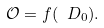<formula> <loc_0><loc_0><loc_500><loc_500>\mathcal { O } = f ( \ D _ { 0 } ) .</formula> 